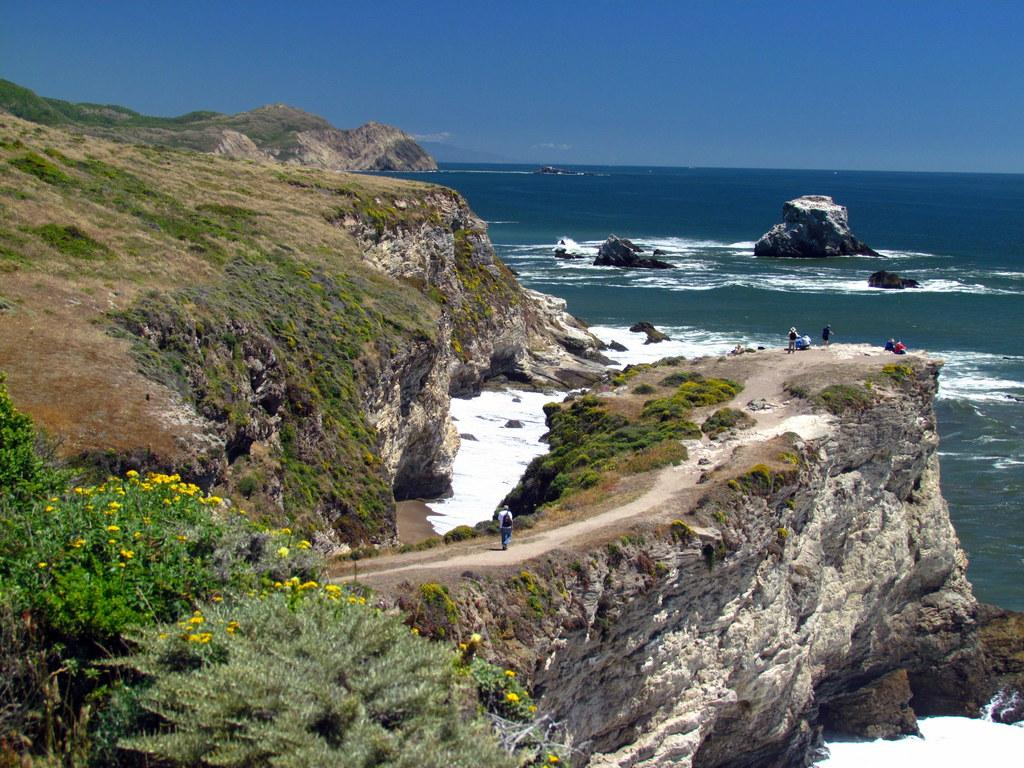What type of plants are on the left side of the image? There are plants with flowers on the left side of the image. Where are the persons located in the image? The persons are on a cliff in the image. What can be seen in the background of the image? Rocks in the water, a cliff, and clouds in the sky are visible in the background of the image. What type of soda is being served on the cliff in the image? There is no soda present in the image; it features plants, persons on a cliff, and a background with rocks, a cliff, and clouds. What is the engine used for in the image? There is no engine present in the image. 